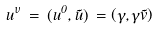<formula> <loc_0><loc_0><loc_500><loc_500>u ^ { \nu } \, = \, ( u ^ { 0 } , \vec { u } ) \, = \left ( \gamma , \gamma \vec { v } \right )</formula> 